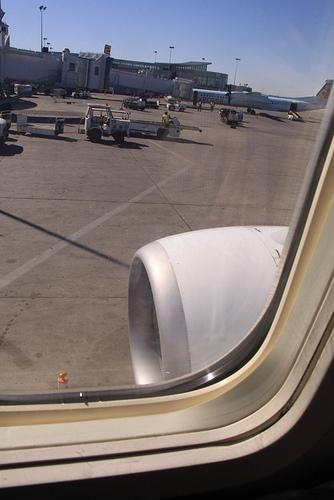Question: where was the photo taken?
Choices:
A. The Grand Canyon.
B. The Eiffel Tower.
C. An airport.
D. A lake.
Answer with the letter. Answer: C Question: what color is the building?
Choices:
A. White.
B. Red.
C. Blue.
D. Black.
Answer with the letter. Answer: A Question: what is the ground made of?
Choices:
A. Dirt.
B. Hard wood.
C. Cement.
D. Rubberized flooring.
Answer with the letter. Answer: C 